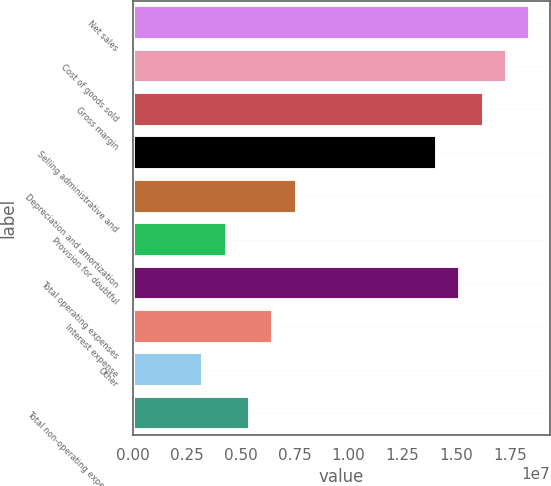Convert chart to OTSL. <chart><loc_0><loc_0><loc_500><loc_500><bar_chart><fcel>Net sales<fcel>Cost of goods sold<fcel>Gross margin<fcel>Selling administrative and<fcel>Depreciation and amortization<fcel>Provision for doubtful<fcel>Total operating expenses<fcel>Interest expense<fcel>Other<fcel>Total non-operating expenses<nl><fcel>1.84334e+07<fcel>1.73491e+07<fcel>1.62648e+07<fcel>1.40962e+07<fcel>7.59024e+06<fcel>4.33728e+06<fcel>1.51805e+07<fcel>6.50592e+06<fcel>3.25296e+06<fcel>5.4216e+06<nl></chart> 